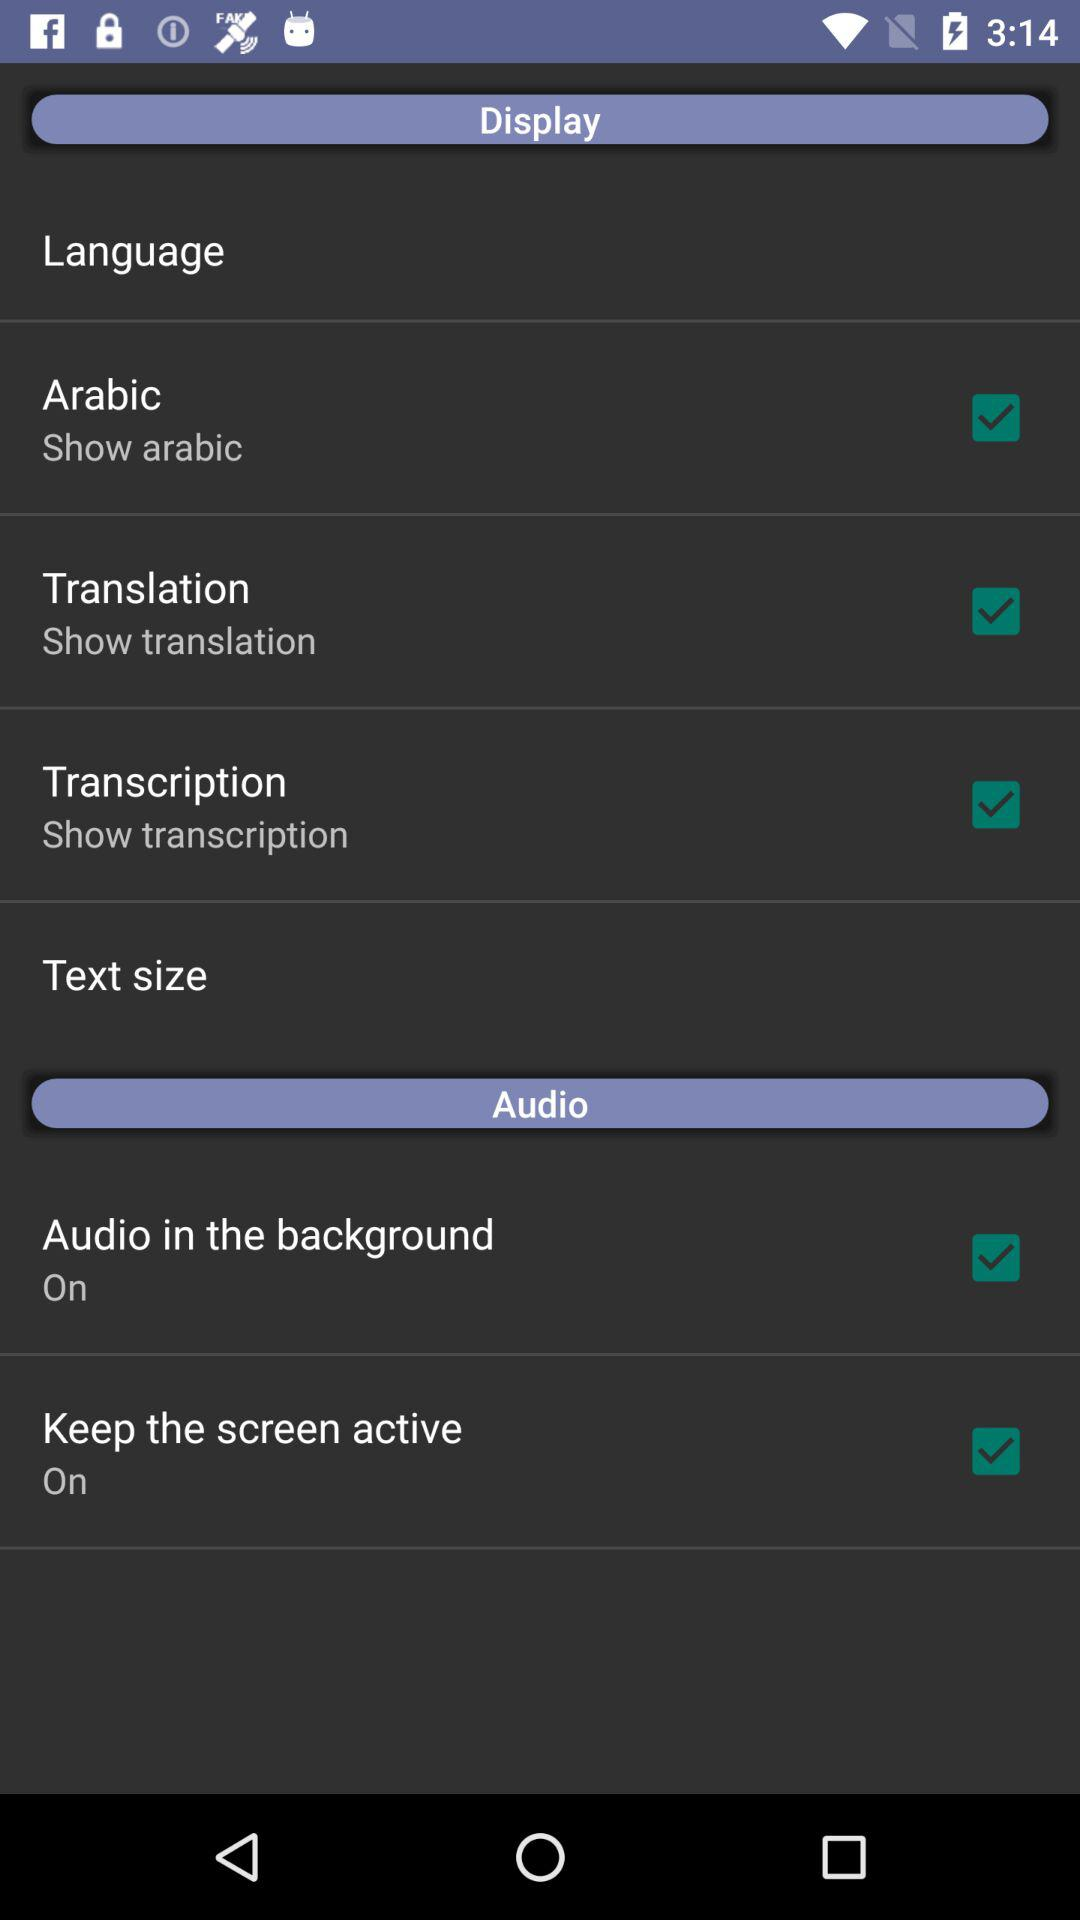How many audio options are available?
Answer the question using a single word or phrase. 2 